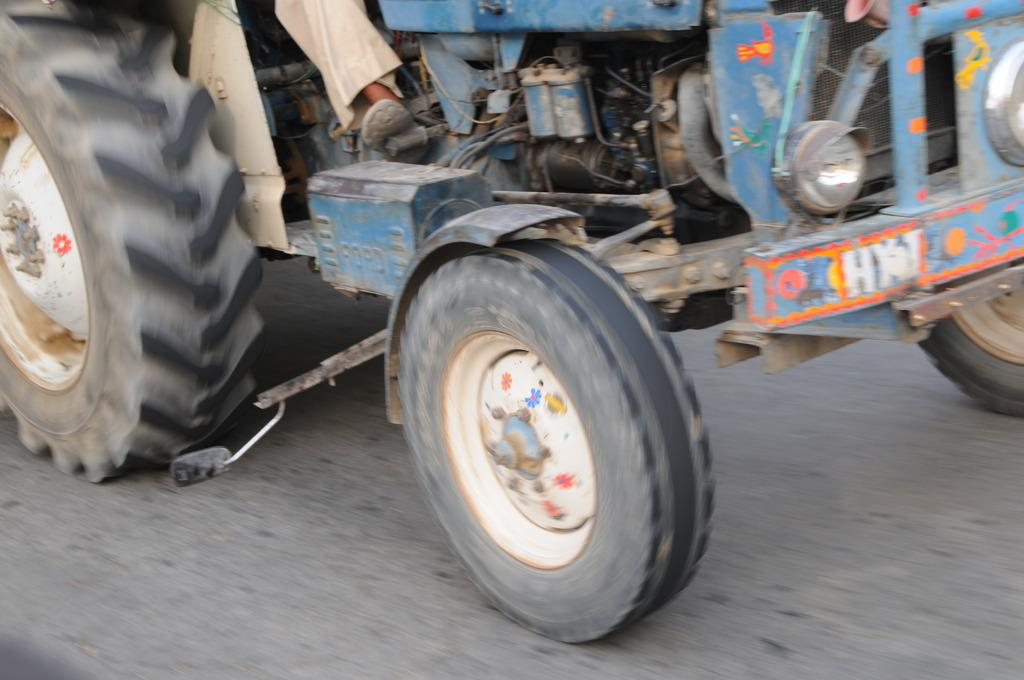What is the main subject of the image? The main subject of the image is a tractor. Where is the tractor located in the image? The tractor is on the road in the image. Who is operating the tractor? There is a man sitting in the driver seat of the tractor. What are some features of the tractor? The tractor has tires, a motor, and headlights. What level of care does the tractor require in the image? The image does not provide information about the level of care required for the tractor. How far does the tractor stretch across the road in the image? The image does not provide information about the length of the tractor or how much of the road it covers. 